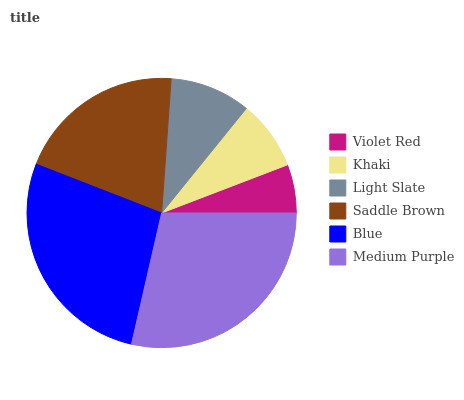Is Violet Red the minimum?
Answer yes or no. Yes. Is Medium Purple the maximum?
Answer yes or no. Yes. Is Khaki the minimum?
Answer yes or no. No. Is Khaki the maximum?
Answer yes or no. No. Is Khaki greater than Violet Red?
Answer yes or no. Yes. Is Violet Red less than Khaki?
Answer yes or no. Yes. Is Violet Red greater than Khaki?
Answer yes or no. No. Is Khaki less than Violet Red?
Answer yes or no. No. Is Saddle Brown the high median?
Answer yes or no. Yes. Is Light Slate the low median?
Answer yes or no. Yes. Is Khaki the high median?
Answer yes or no. No. Is Saddle Brown the low median?
Answer yes or no. No. 